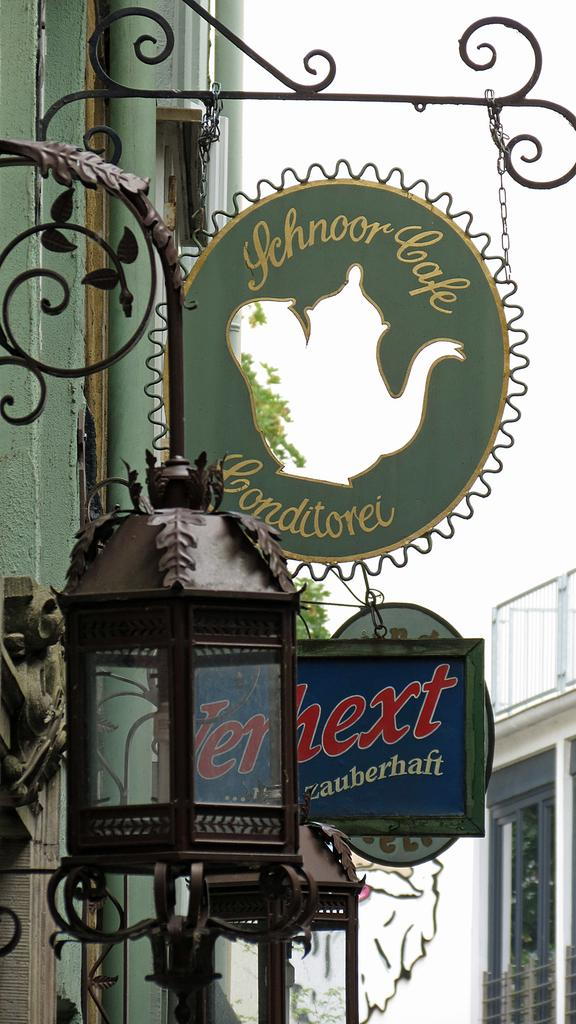What type of lighting is present in the image? There are lanterns in the image. What structure can be seen on a pole in the image? There are boards on a pole in the image. What can be seen on the left side of the image? There is a building on the left side of the image. What can be seen on the right side of the image? There is a building on the right side of the image. What type of knife is being used to open the soda in the image? There is no knife or soda present in the image. How many men are visible in the image? There are no men visible in the image. 